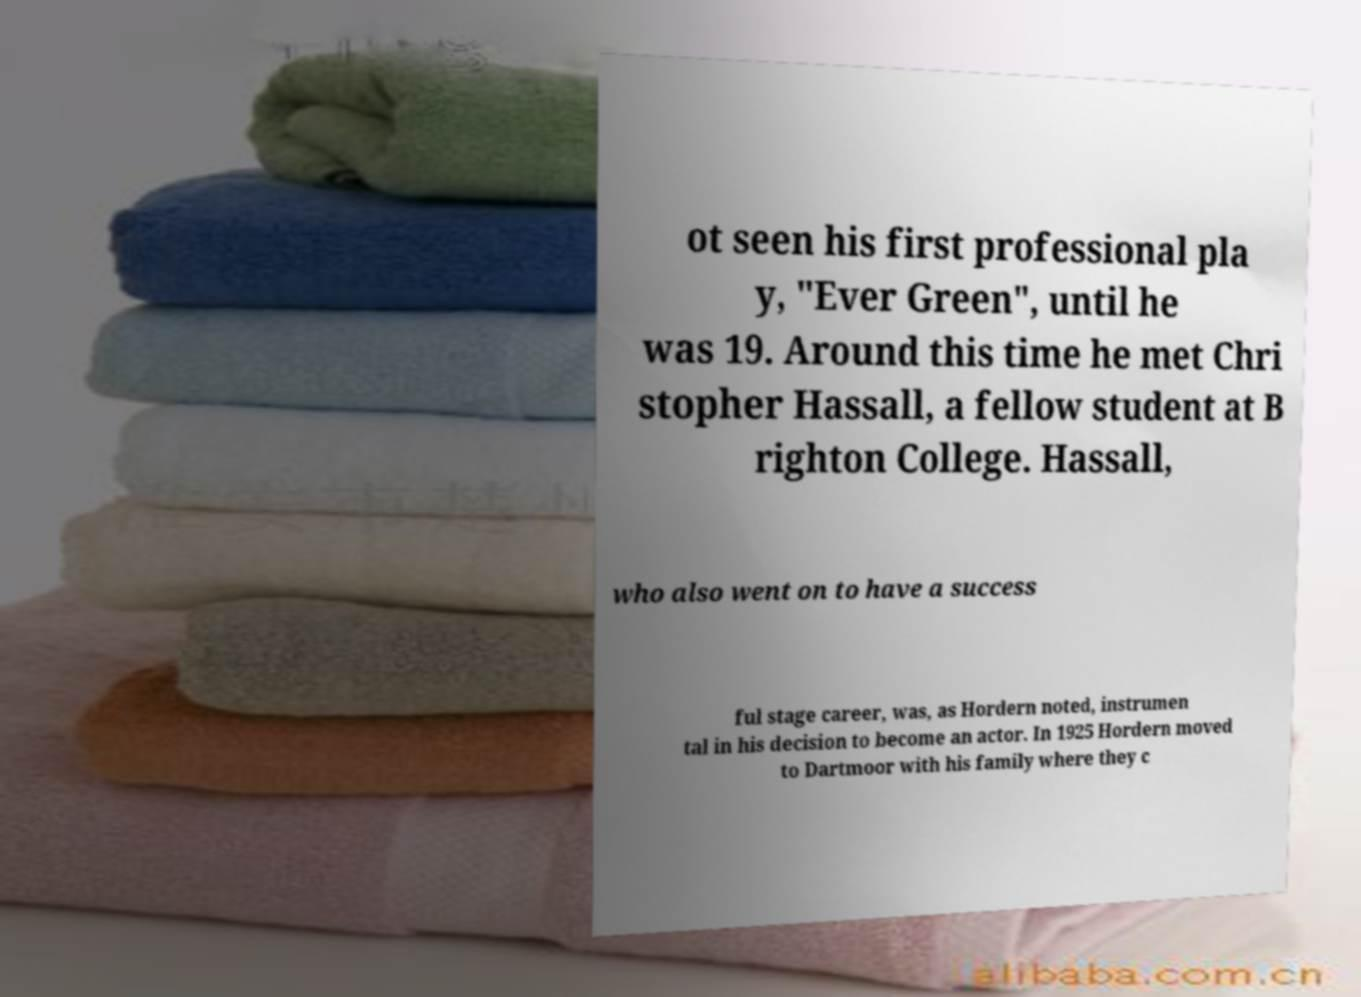There's text embedded in this image that I need extracted. Can you transcribe it verbatim? ot seen his first professional pla y, "Ever Green", until he was 19. Around this time he met Chri stopher Hassall, a fellow student at B righton College. Hassall, who also went on to have a success ful stage career, was, as Hordern noted, instrumen tal in his decision to become an actor. In 1925 Hordern moved to Dartmoor with his family where they c 